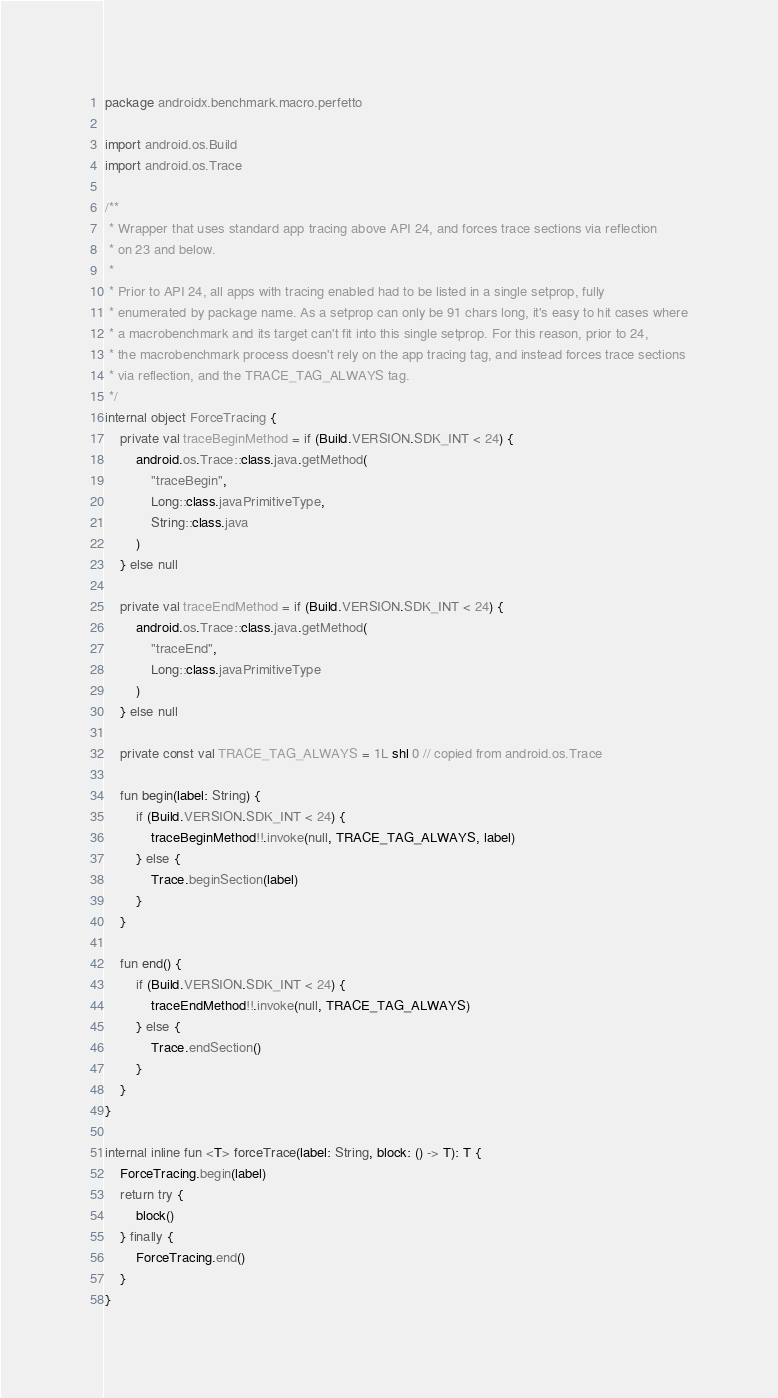Convert code to text. <code><loc_0><loc_0><loc_500><loc_500><_Kotlin_>
package androidx.benchmark.macro.perfetto

import android.os.Build
import android.os.Trace

/**
 * Wrapper that uses standard app tracing above API 24, and forces trace sections via reflection
 * on 23 and below.
 *
 * Prior to API 24, all apps with tracing enabled had to be listed in a single setprop, fully
 * enumerated by package name. As a setprop can only be 91 chars long, it's easy to hit cases where
 * a macrobenchmark and its target can't fit into this single setprop. For this reason, prior to 24,
 * the macrobenchmark process doesn't rely on the app tracing tag, and instead forces trace sections
 * via reflection, and the TRACE_TAG_ALWAYS tag.
 */
internal object ForceTracing {
    private val traceBeginMethod = if (Build.VERSION.SDK_INT < 24) {
        android.os.Trace::class.java.getMethod(
            "traceBegin",
            Long::class.javaPrimitiveType,
            String::class.java
        )
    } else null

    private val traceEndMethod = if (Build.VERSION.SDK_INT < 24) {
        android.os.Trace::class.java.getMethod(
            "traceEnd",
            Long::class.javaPrimitiveType
        )
    } else null

    private const val TRACE_TAG_ALWAYS = 1L shl 0 // copied from android.os.Trace

    fun begin(label: String) {
        if (Build.VERSION.SDK_INT < 24) {
            traceBeginMethod!!.invoke(null, TRACE_TAG_ALWAYS, label)
        } else {
            Trace.beginSection(label)
        }
    }

    fun end() {
        if (Build.VERSION.SDK_INT < 24) {
            traceEndMethod!!.invoke(null, TRACE_TAG_ALWAYS)
        } else {
            Trace.endSection()
        }
    }
}

internal inline fun <T> forceTrace(label: String, block: () -> T): T {
    ForceTracing.begin(label)
    return try {
        block()
    } finally {
        ForceTracing.end()
    }
}
</code> 